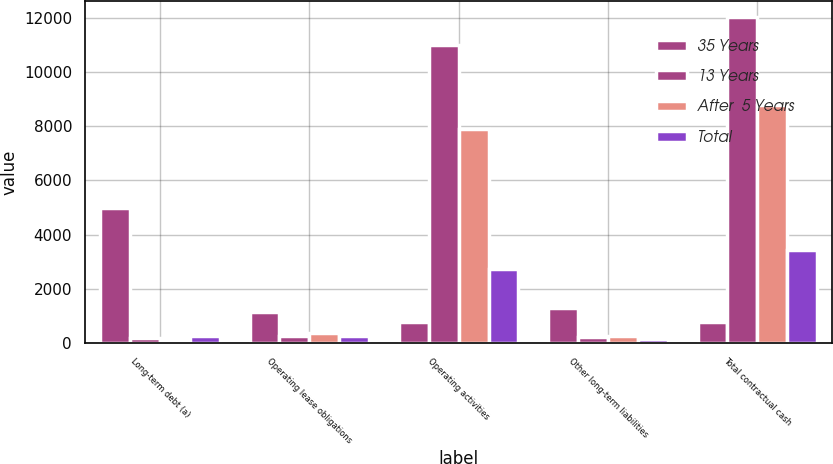Convert chart to OTSL. <chart><loc_0><loc_0><loc_500><loc_500><stacked_bar_chart><ecel><fcel>Long-term debt (a)<fcel>Operating lease obligations<fcel>Operating activities<fcel>Other long-term liabilities<fcel>Total contractual cash<nl><fcel>35 Years<fcel>4986<fcel>1157<fcel>771.5<fcel>1289<fcel>771.5<nl><fcel>13 Years<fcel>202<fcel>261<fcel>11001<fcel>213<fcel>12021<nl><fcel>After  5 Years<fcel>136<fcel>386<fcel>7880<fcel>256<fcel>8776<nl><fcel>Total<fcel>248<fcel>262<fcel>2752<fcel>169<fcel>3431<nl></chart> 